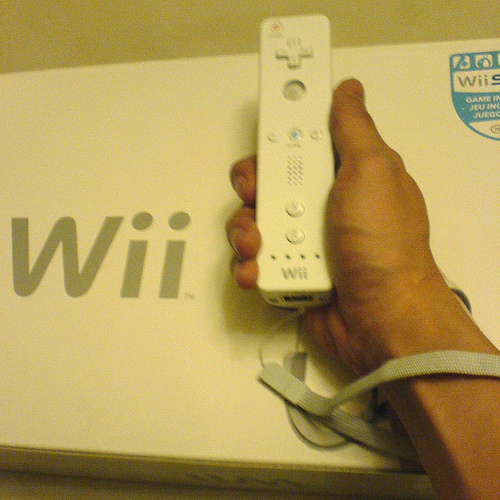Please transcribe the text in this image. wii wii GAME S 